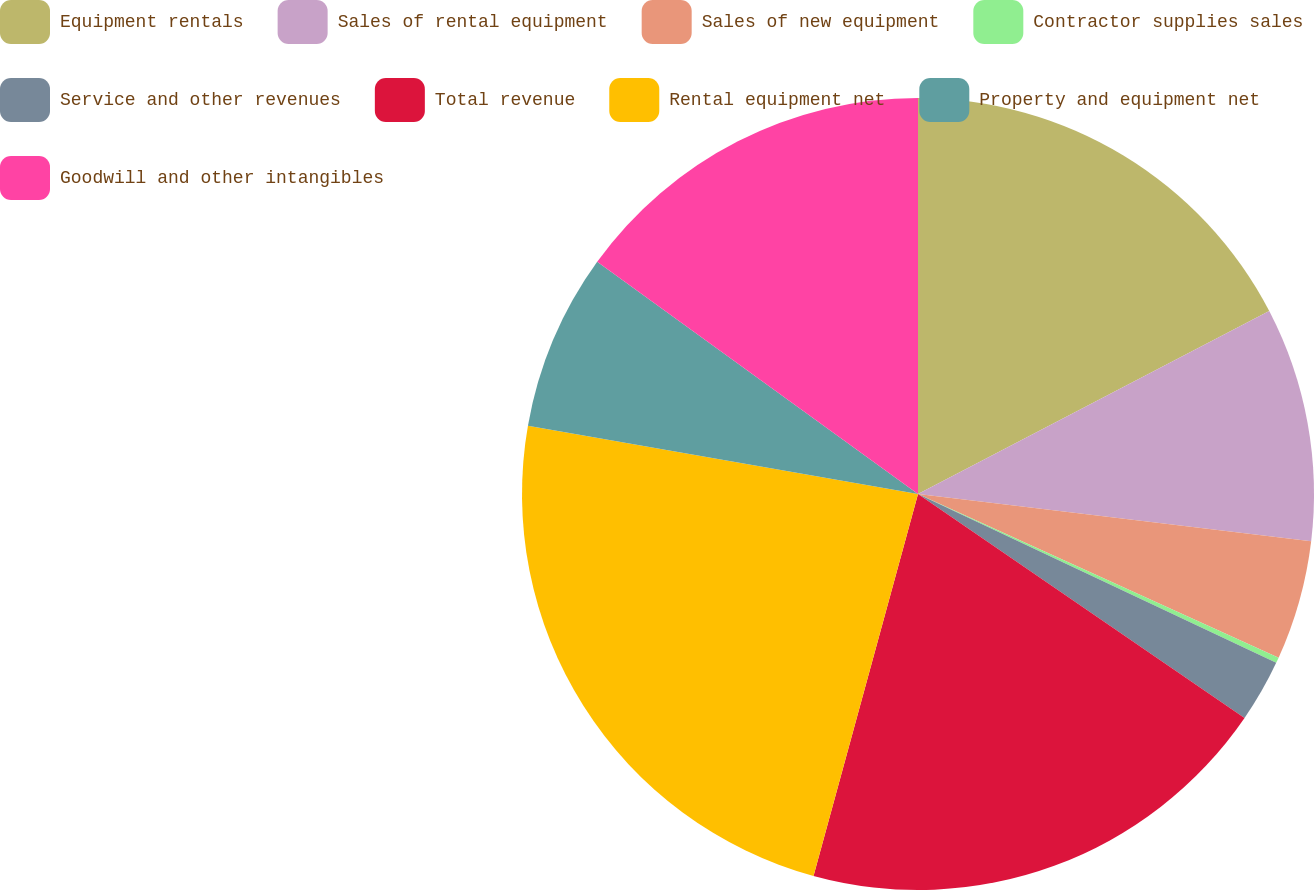Convert chart. <chart><loc_0><loc_0><loc_500><loc_500><pie_chart><fcel>Equipment rentals<fcel>Sales of rental equipment<fcel>Sales of new equipment<fcel>Contractor supplies sales<fcel>Service and other revenues<fcel>Total revenue<fcel>Rental equipment net<fcel>Property and equipment net<fcel>Goodwill and other intangibles<nl><fcel>17.36%<fcel>9.54%<fcel>4.88%<fcel>0.23%<fcel>2.56%<fcel>19.68%<fcel>23.51%<fcel>7.21%<fcel>15.03%<nl></chart> 